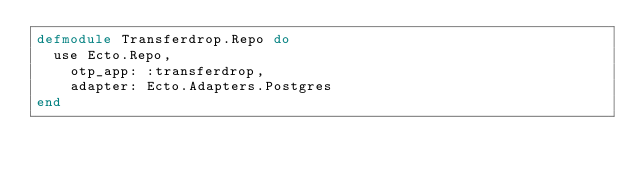Convert code to text. <code><loc_0><loc_0><loc_500><loc_500><_Elixir_>defmodule Transferdrop.Repo do
  use Ecto.Repo,
    otp_app: :transferdrop,
    adapter: Ecto.Adapters.Postgres
end
</code> 